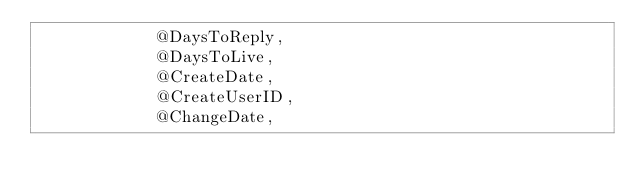<code> <loc_0><loc_0><loc_500><loc_500><_SQL_>            @DaysToReply,
            @DaysToLive,
            @CreateDate,
            @CreateUserID,
            @ChangeDate,</code> 